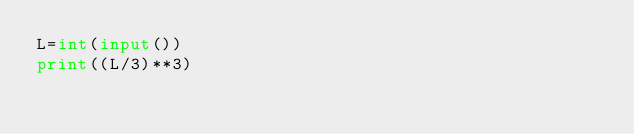Convert code to text. <code><loc_0><loc_0><loc_500><loc_500><_Python_>L=int(input())
print((L/3)**3)</code> 